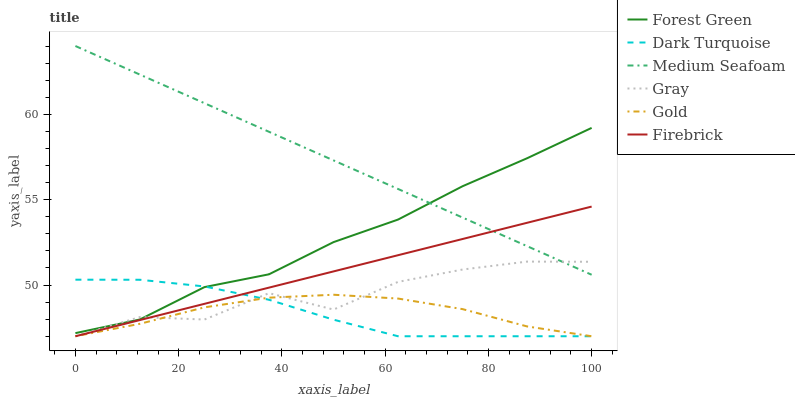Does Dark Turquoise have the minimum area under the curve?
Answer yes or no. Yes. Does Medium Seafoam have the maximum area under the curve?
Answer yes or no. Yes. Does Gold have the minimum area under the curve?
Answer yes or no. No. Does Gold have the maximum area under the curve?
Answer yes or no. No. Is Medium Seafoam the smoothest?
Answer yes or no. Yes. Is Gray the roughest?
Answer yes or no. Yes. Is Gold the smoothest?
Answer yes or no. No. Is Gold the roughest?
Answer yes or no. No. Does Forest Green have the lowest value?
Answer yes or no. No. Does Medium Seafoam have the highest value?
Answer yes or no. Yes. Does Dark Turquoise have the highest value?
Answer yes or no. No. Is Gold less than Forest Green?
Answer yes or no. Yes. Is Forest Green greater than Firebrick?
Answer yes or no. Yes. Does Dark Turquoise intersect Forest Green?
Answer yes or no. Yes. Is Dark Turquoise less than Forest Green?
Answer yes or no. No. Is Dark Turquoise greater than Forest Green?
Answer yes or no. No. Does Gold intersect Forest Green?
Answer yes or no. No. 